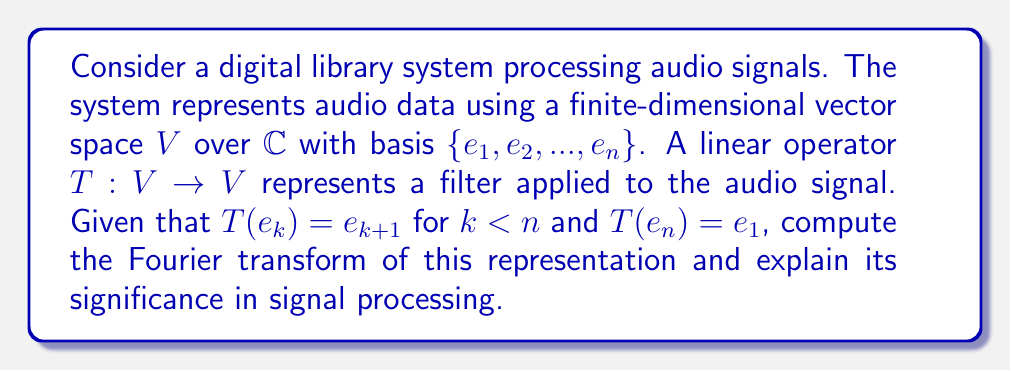Help me with this question. Let's approach this step-by-step:

1) First, we need to understand that the given operator $T$ is a cyclic permutation of the basis vectors. This is a common representation in signal processing, often used for cyclic shifts or circular convolutions.

2) To compute the Fourier transform of this representation, we need to find the eigenvalues and eigenvectors of $T$. The characteristic polynomial of $T$ is $x^n - 1 = 0$.

3) The solutions to this equation are the $n$-th roots of unity:
   $$\lambda_k = e^{2\pi i k/n}, \quad k = 0, 1, ..., n-1$$

4) For each eigenvalue $\lambda_k$, the corresponding eigenvector $v_k$ satisfies:
   $$T v_k = \lambda_k v_k$$

5) We can verify that the eigenvectors have the form:
   $$v_k = (1, \lambda_k, \lambda_k^2, ..., \lambda_k^{n-1})^T$$

6) The Fourier transform of this representation is essentially the change of basis from $\{e_1, ..., e_n\}$ to $\{v_0, ..., v_{n-1}\}$. This change of basis matrix is the Discrete Fourier Transform (DFT) matrix:

   $$F = \frac{1}{\sqrt{n}} (\lambda_k^j)_{j,k=0}^{n-1} = \frac{1}{\sqrt{n}} (e^{2\pi i jk/n})_{j,k=0}^{n-1}$$

7) In this new basis, $T$ is represented by a diagonal matrix $D$ with the eigenvalues on the diagonal:
   $$D = \text{diag}(1, e^{2\pi i/n}, e^{4\pi i/n}, ..., e^{2\pi i(n-1)/n})$$

8) The significance in signal processing:
   - The Fourier transform decomposes the signal into frequency components.
   - The cyclic nature of $T$ becomes evident in the frequency domain as phase shifts.
   - Operations like circular convolution become simple multiplications in the frequency domain.
   - This transformation enables efficient computation of certain signal processing operations.
Answer: The Fourier transform of the representation is the DFT matrix $F = \frac{1}{\sqrt{n}} (e^{2\pi i jk/n})_{j,k=0}^{n-1}$, diagonalizing $T$ to $D = \text{diag}(1, e^{2\pi i/n}, ..., e^{2\pi i(n-1)/n})$. 